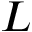Convert formula to latex. <formula><loc_0><loc_0><loc_500><loc_500>L</formula> 